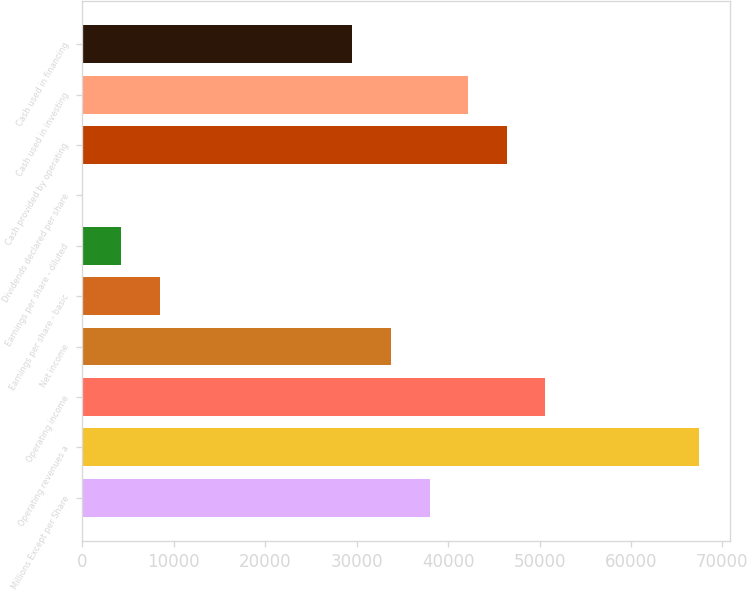Convert chart to OTSL. <chart><loc_0><loc_0><loc_500><loc_500><bar_chart><fcel>Millions Except per Share<fcel>Operating revenues a<fcel>Operating income<fcel>Net income<fcel>Earnings per share - basic<fcel>Earnings per share - diluted<fcel>Dividends declared per share<fcel>Cash provided by operating<fcel>Cash used in investing<fcel>Cash used in financing<nl><fcel>37965.7<fcel>67493.7<fcel>50620.6<fcel>33747.4<fcel>8437.66<fcel>4219.37<fcel>1.08<fcel>46402.3<fcel>42184<fcel>29529.1<nl></chart> 